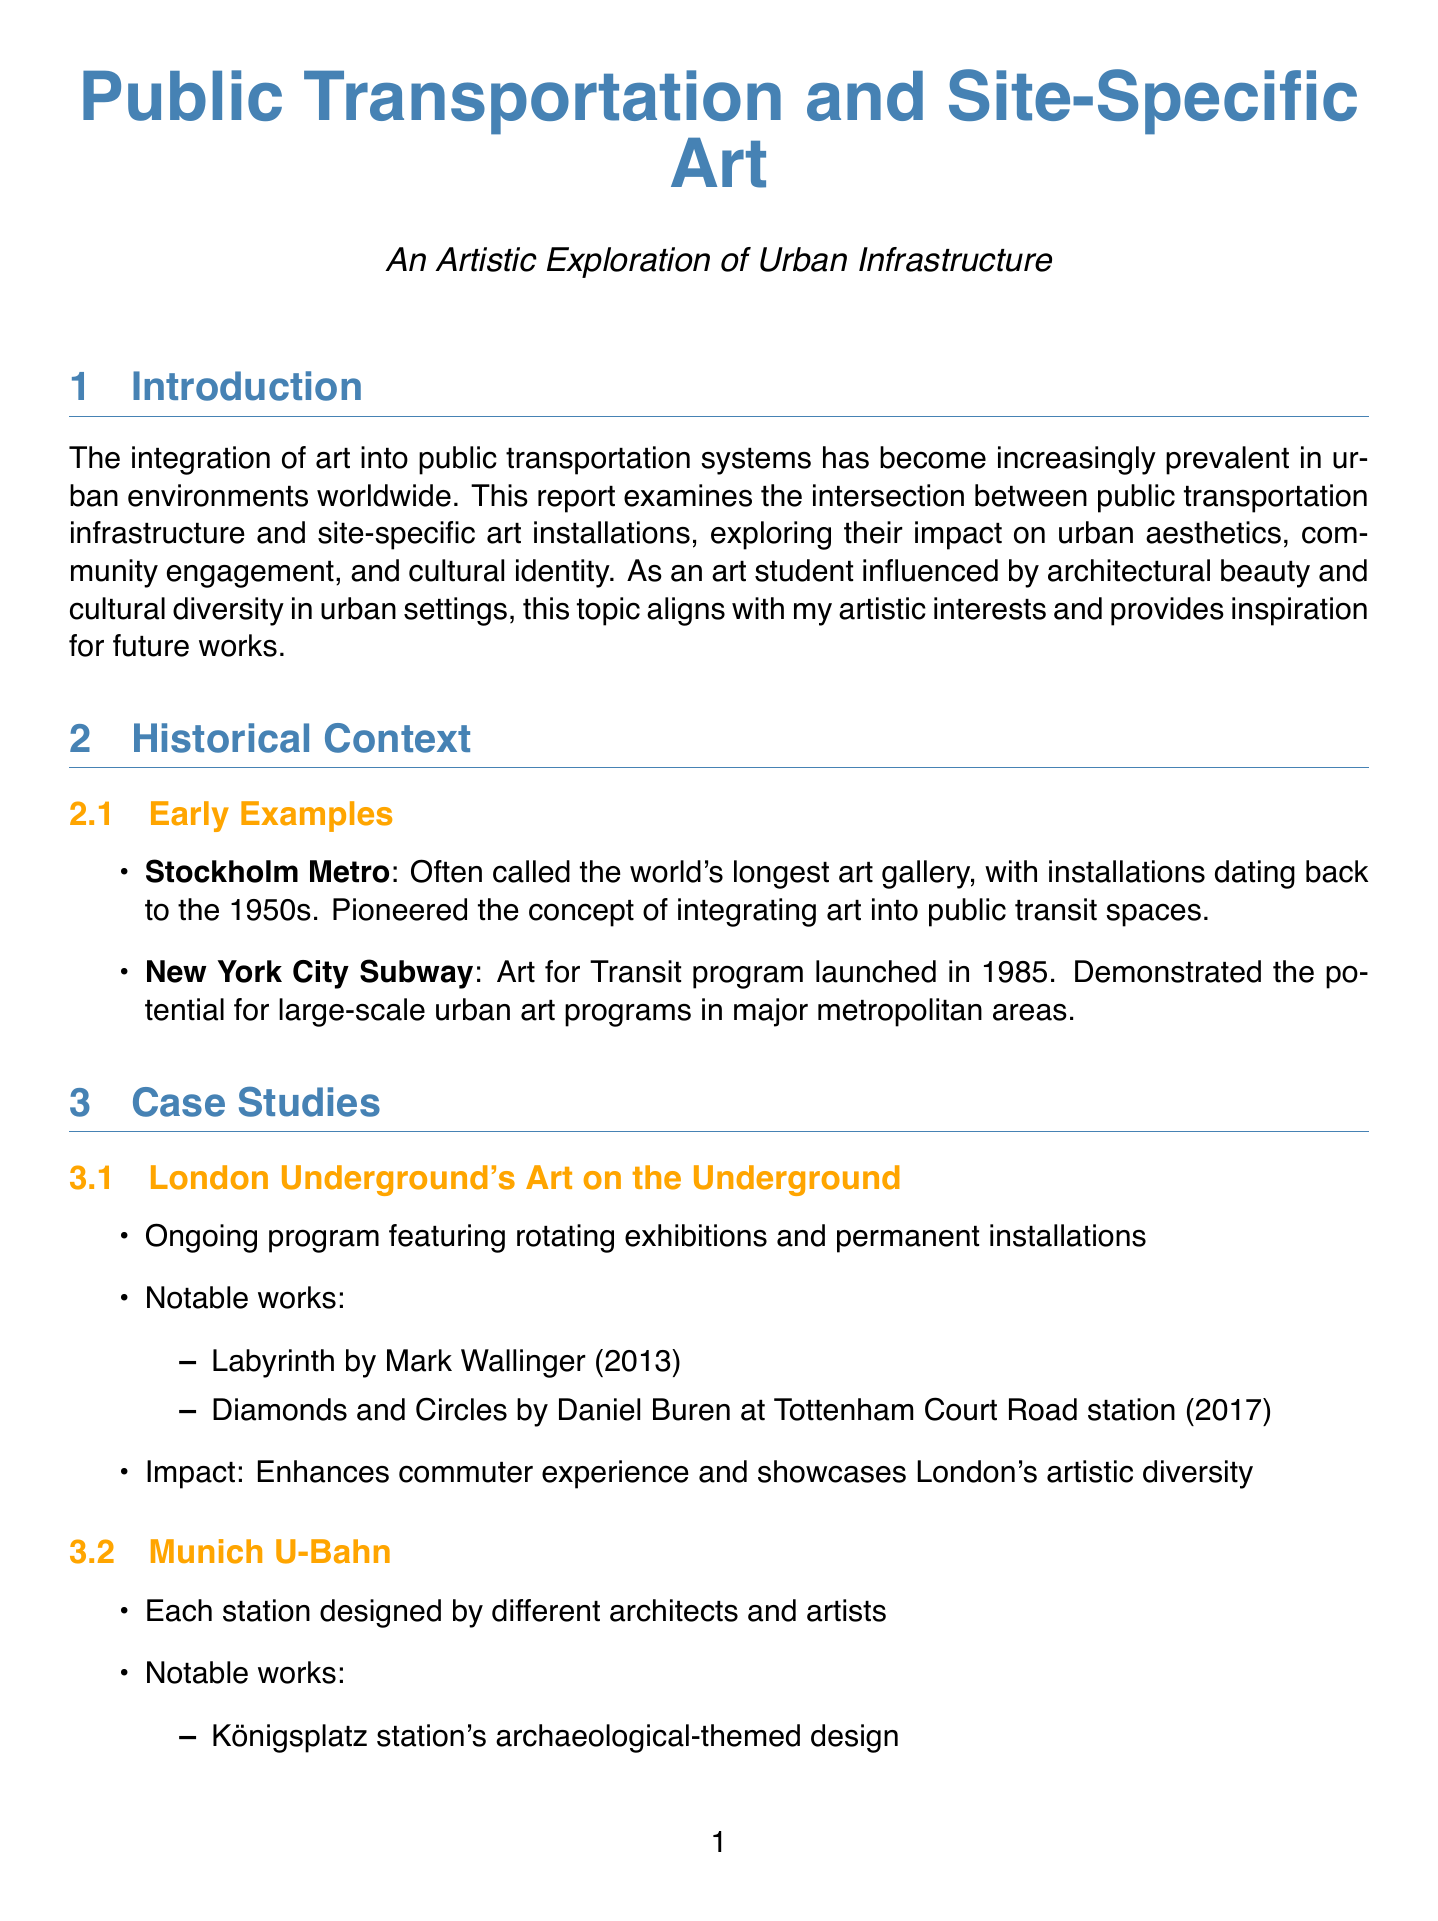what is often called the world's longest art gallery? Stockholm Metro is referred to as the world's longest art gallery, highlighting its extensive collection of art installations.
Answer: Stockholm Metro when was the Art for Transit program launched in New York City Subway? The report states that the Art for Transit program was initiated in 1985, marking a significant step in urban art programs.
Answer: 1985 what notable work was created by Mark Wallinger? The document mentions "Labyrinth" as a notable work by Mark Wallinger that is part of the ongoing initiative in the London Underground.
Answer: Labyrinth what is a significant challenge mentioned regarding public transportation art installations? One of the challenges outlined is the need for balancing artistic vision with practical considerations, which can affect project implementation.
Answer: Balancing artistic vision with practical considerations what innovative approach uses interactive technology in public transportation art? The document describes the Arts in Transit program at Singapore's Dhoby Ghaut MRT station as incorporating interactive LED displays that react to passenger movement, showcasing the integration of technology in art.
Answer: Digital art installations what future trend involves environmental sustainability in art installations? The report highlights a growing focus on sustainable and eco-friendly art installations as a trend for the future, emphasizing environmental considerations in urban art.
Answer: Sustainable and eco-friendly art installations which station features an archaeological-themed design? The document lists Königsplatz station as having an archaeological-themed design, showcasing how art can reflect historical context within transport systems.
Answer: Königsplatz station who collaborates with local schools in community-driven projects? The report indicates that Philadelphia's SEPTA Art in Transit program fosters collaboration with local schools and community organizations to enhance public art's community impact.
Answer: Local schools what does the conclusion emphasize about the future of art in transit spaces? The conclusion underscores that the continuous integration of art in transit systems will transform cities into more vibrant, engaging, and culturally rich environments.
Answer: Culturally rich environments 